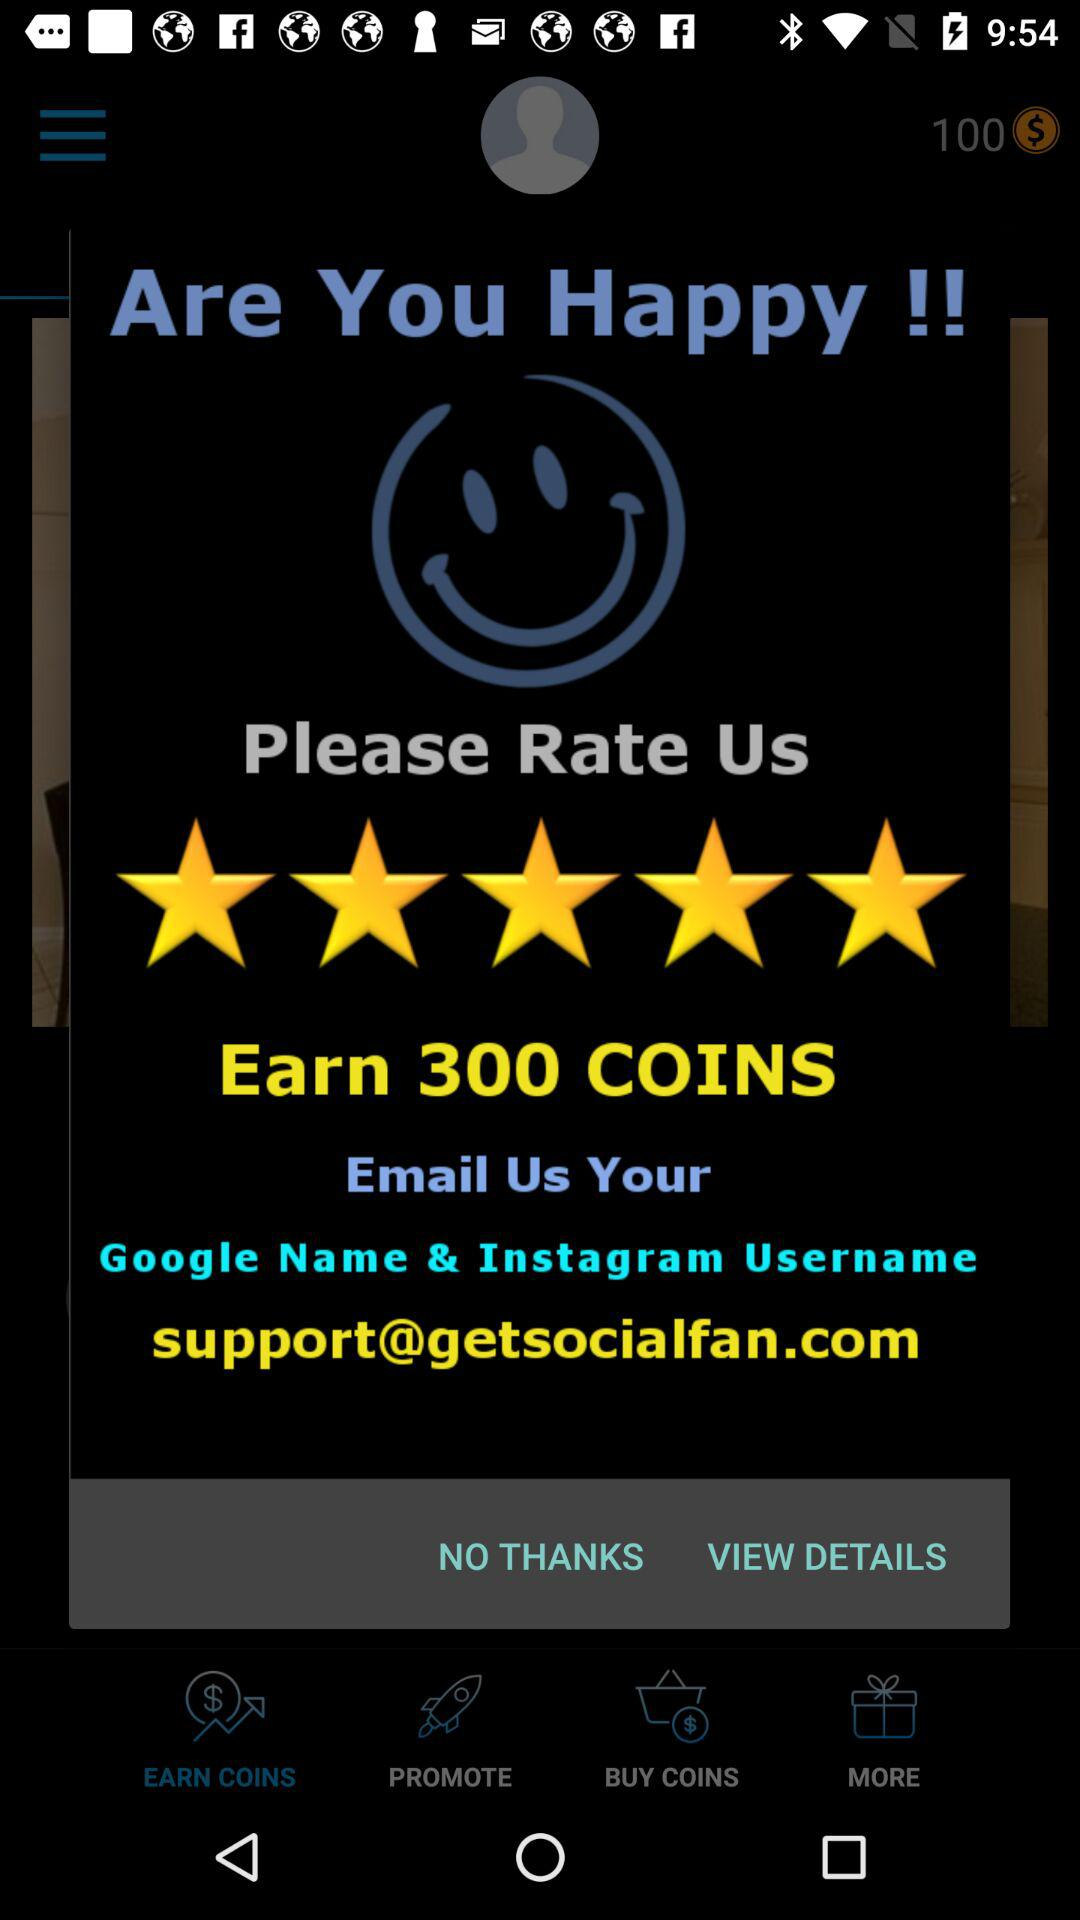How many coins can we earn? You can earn 300 coins. 